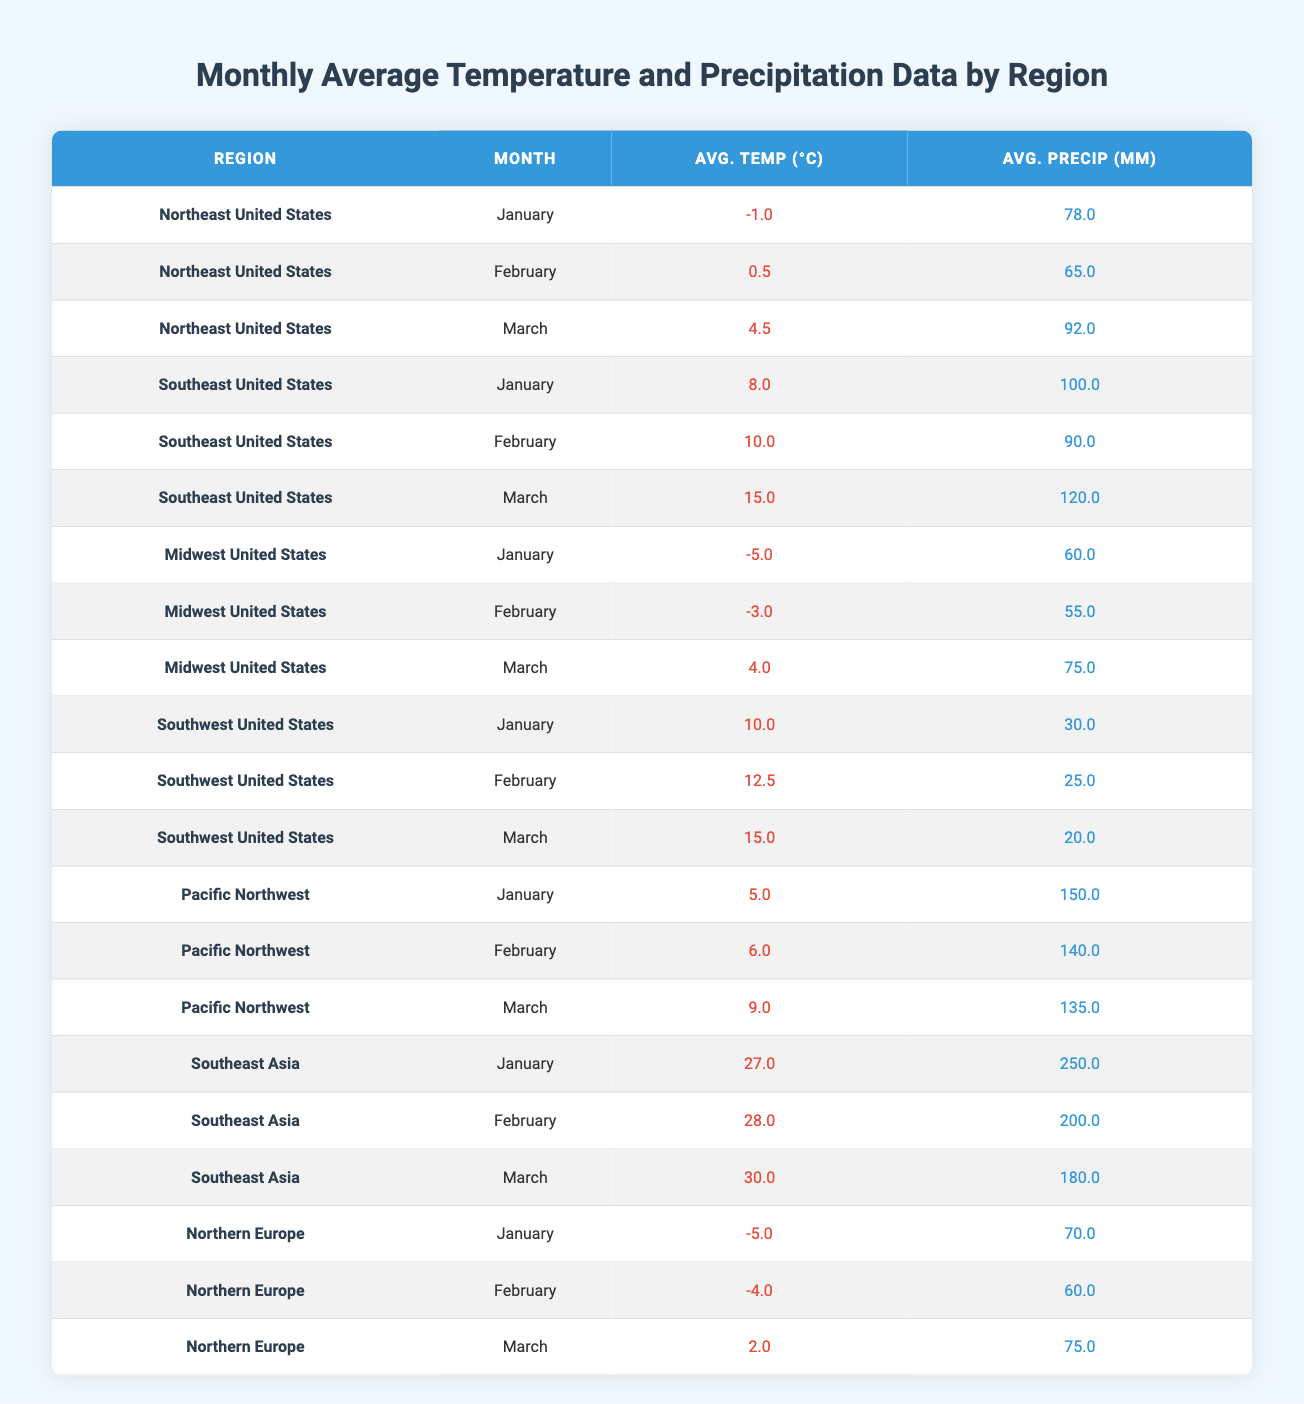What is the average temperature in the Northeast United States for March? The average temperature for March in the Northeast United States is given in the table as 4.5°C.
Answer: 4.5°C What is the total precipitation for the Southeast United States in January, February, and March combined? To find the total precipitation for the Southeast United States, we add the values for January (100.0 mm), February (90.0 mm), and March (120.0 mm): 100.0 + 90.0 + 120.0 = 310.0 mm.
Answer: 310.0 mm Is the average temperature in the Pacific Northwest higher in March than in January? For the Pacific Northwest, the average temperature in March is 9.0°C and in January, it is 5.0°C. Since 9.0°C > 5.0°C, the statement is true.
Answer: Yes What region recorded the highest average precipitation in January? The table shows that Southeast Asia recorded an average precipitation of 250.0 mm in January, which is the highest among all regions listed.
Answer: Southeast Asia What is the difference in average temperature between the Midwest United States in January and March? The average temperature for the Midwest United States in January is -5.0°C, and in March, it is 4.0°C. To find the difference, we calculate 4.0 - (-5.0) = 4.0 + 5.0 = 9.0°C.
Answer: 9.0°C Does the Northeast United States have more average precipitation in March compared to the Midwest United States in the same month? In March, the Northeast United States has an average precipitation of 92.0 mm, while the Midwest United States has 75.0 mm. Since 92.0 mm > 75.0 mm, the answer is yes.
Answer: Yes What is the average precipitation for the Southeast Asia region over the three months provided? For Southeast Asia, the precipitation values are 250.0 mm (January), 200.0 mm (February), and 180.0 mm (March). We calculate the average as follows: (250.0 + 200.0 + 180.0) / 3 = 630.0 / 3 = 210.0 mm.
Answer: 210.0 mm Which region has the lowest average temperature in February? In February, the Midwest United States has an average temperature of -3.0°C, which is the lowest compared to the other regions listed in the table.
Answer: Midwest United States What is the average temperature across all regions for the month of March? To find the average temperature for March, we sum the average temperatures for all regions: 4.5 (Northeast) + 15.0 (Southeast) + 4.0 (Midwest) + 15.0 (Southwest) + 9.0 (Pacific Northwest) + 30.0 (Southeast Asia) + 2.0 (Northern Europe) = 75.5°C. There are 7 regions, so the average is 75.5 / 7 ≈ 10.79°C.
Answer: 10.79°C 